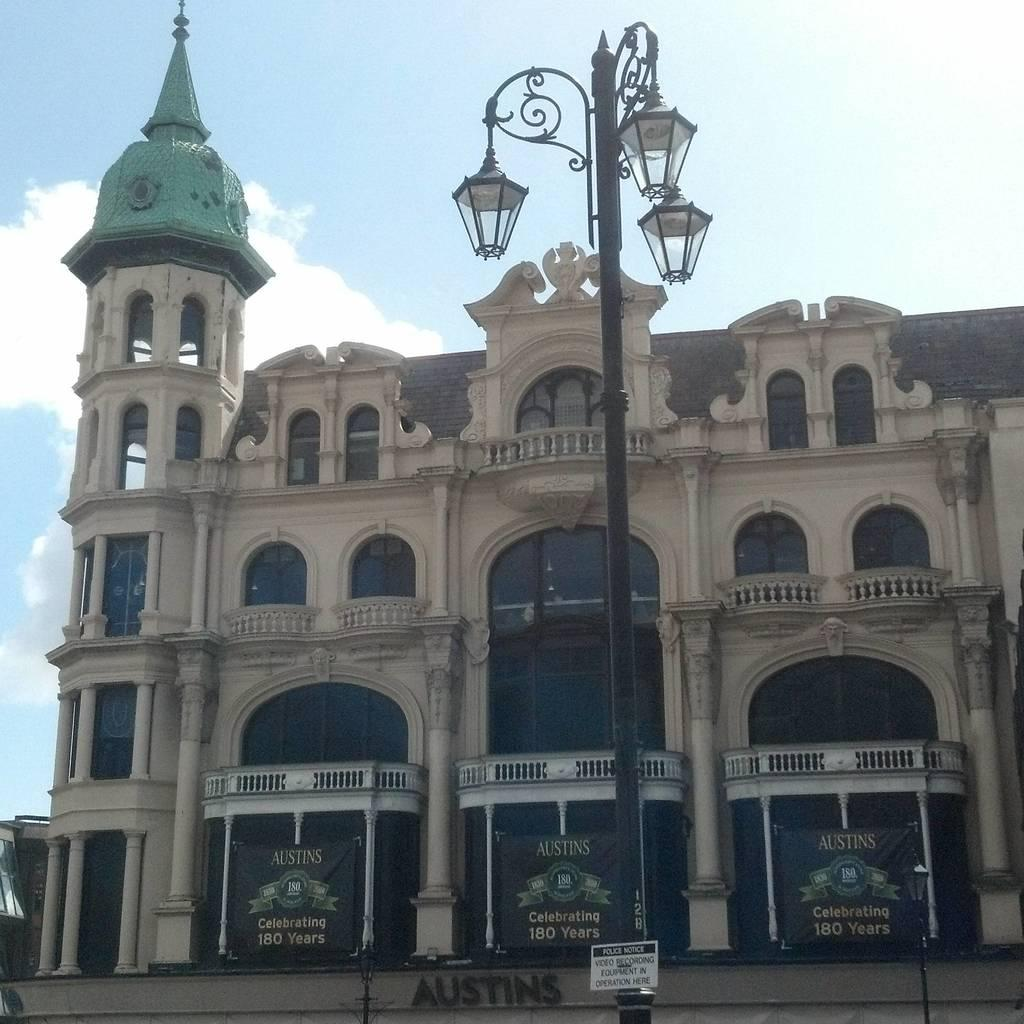<image>
Create a compact narrative representing the image presented. A building with three black banners that advertise Austins. 